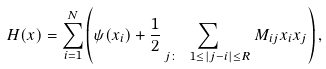<formula> <loc_0><loc_0><loc_500><loc_500>H ( x ) = \sum _ { i = 1 } ^ { N } \left ( \psi ( x _ { i } ) + \frac { 1 } { 2 } \sum _ { j \colon \ 1 \leq | j - i | \leq R } M _ { i j } x _ { i } x _ { j } \right ) ,</formula> 